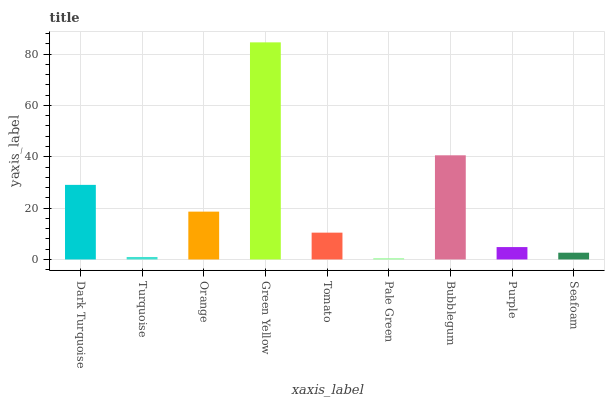Is Turquoise the minimum?
Answer yes or no. No. Is Turquoise the maximum?
Answer yes or no. No. Is Dark Turquoise greater than Turquoise?
Answer yes or no. Yes. Is Turquoise less than Dark Turquoise?
Answer yes or no. Yes. Is Turquoise greater than Dark Turquoise?
Answer yes or no. No. Is Dark Turquoise less than Turquoise?
Answer yes or no. No. Is Tomato the high median?
Answer yes or no. Yes. Is Tomato the low median?
Answer yes or no. Yes. Is Pale Green the high median?
Answer yes or no. No. Is Seafoam the low median?
Answer yes or no. No. 